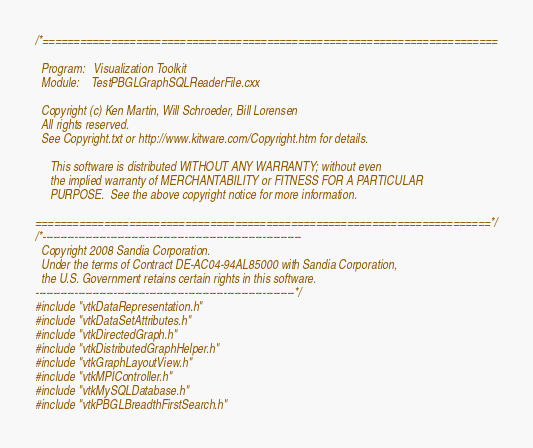Convert code to text. <code><loc_0><loc_0><loc_500><loc_500><_C++_>/*=========================================================================

  Program:   Visualization Toolkit
  Module:    TestPBGLGraphSQLReaderFile.cxx

  Copyright (c) Ken Martin, Will Schroeder, Bill Lorensen
  All rights reserved.
  See Copyright.txt or http://www.kitware.com/Copyright.htm for details.

     This software is distributed WITHOUT ANY WARRANTY; without even
     the implied warranty of MERCHANTABILITY or FITNESS FOR A PARTICULAR
     PURPOSE.  See the above copyright notice for more information.

=========================================================================*/
/*-------------------------------------------------------------------------
  Copyright 2008 Sandia Corporation.
  Under the terms of Contract DE-AC04-94AL85000 with Sandia Corporation,
  the U.S. Government retains certain rights in this software.
-------------------------------------------------------------------------*/
#include "vtkDataRepresentation.h"
#include "vtkDataSetAttributes.h"
#include "vtkDirectedGraph.h"
#include "vtkDistributedGraphHelper.h"
#include "vtkGraphLayoutView.h"
#include "vtkMPIController.h"
#include "vtkMySQLDatabase.h"
#include "vtkPBGLBreadthFirstSearch.h"</code> 